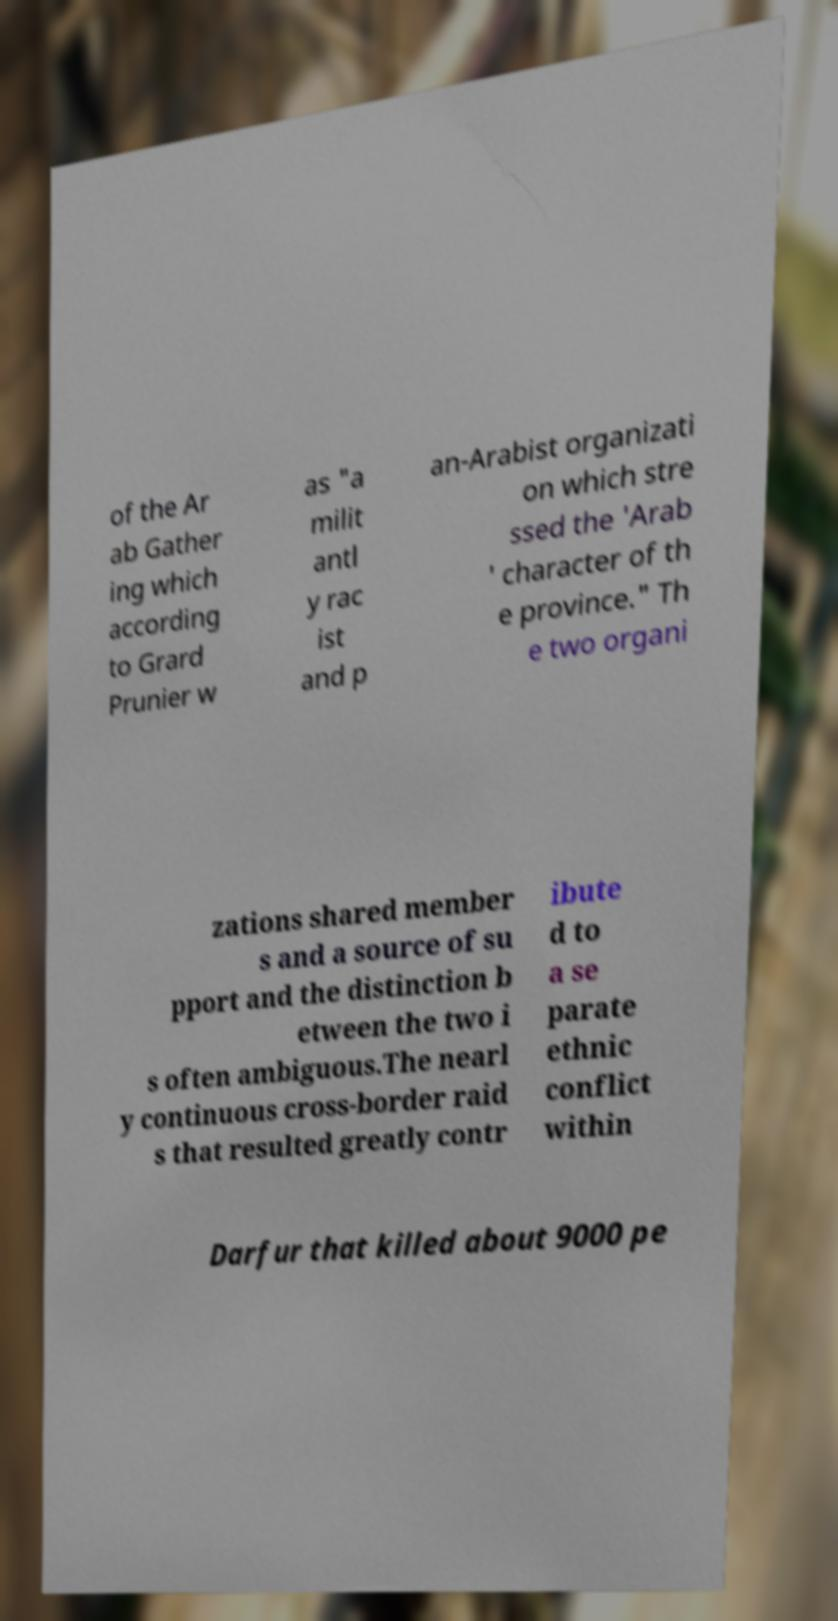Can you read and provide the text displayed in the image?This photo seems to have some interesting text. Can you extract and type it out for me? of the Ar ab Gather ing which according to Grard Prunier w as "a milit antl y rac ist and p an-Arabist organizati on which stre ssed the 'Arab ' character of th e province." Th e two organi zations shared member s and a source of su pport and the distinction b etween the two i s often ambiguous.The nearl y continuous cross-border raid s that resulted greatly contr ibute d to a se parate ethnic conflict within Darfur that killed about 9000 pe 